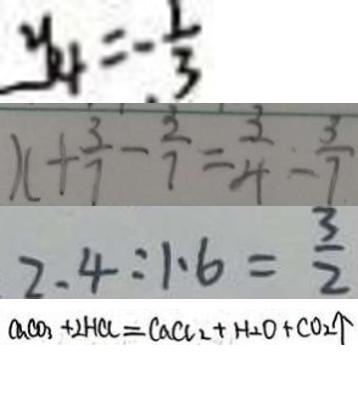Convert formula to latex. <formula><loc_0><loc_0><loc_500><loc_500>y _ { 4 } = - \frac { 1 } { 3 } 
 x + \frac { 3 } { 7 } - \frac { 3 } { 7 } = \frac { 3 } { 4 } - \frac { 3 } { 7 } 
 2 . 4 : 1 . 6 = \frac { 3 } { 2 } 
 C a C O _ { 3 } + 2 H C l = C a C l _ { 2 } + H _ { 2 } O + C O _ { 2 } \uparrow</formula> 